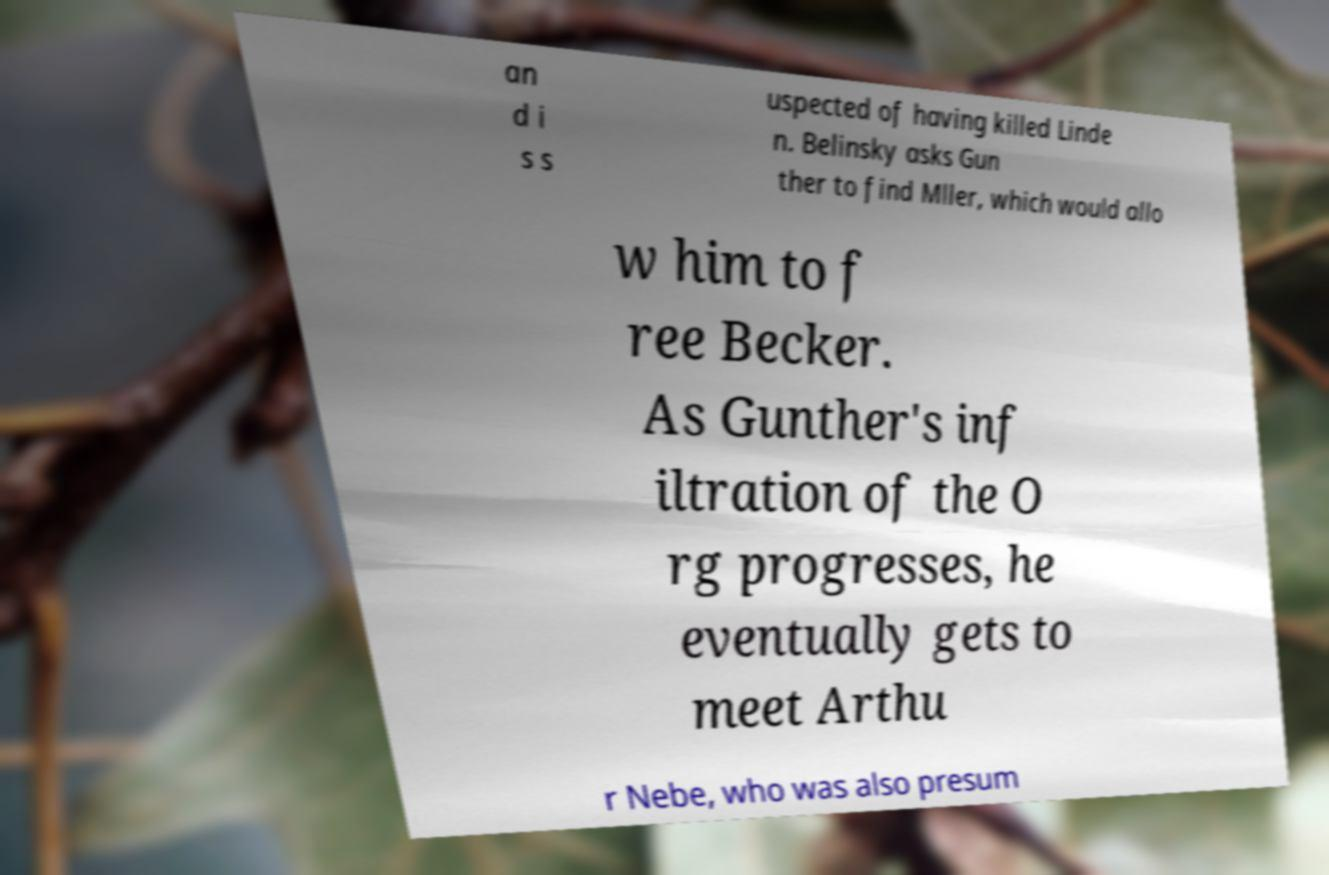I need the written content from this picture converted into text. Can you do that? an d i s s uspected of having killed Linde n. Belinsky asks Gun ther to find Mller, which would allo w him to f ree Becker. As Gunther's inf iltration of the O rg progresses, he eventually gets to meet Arthu r Nebe, who was also presum 